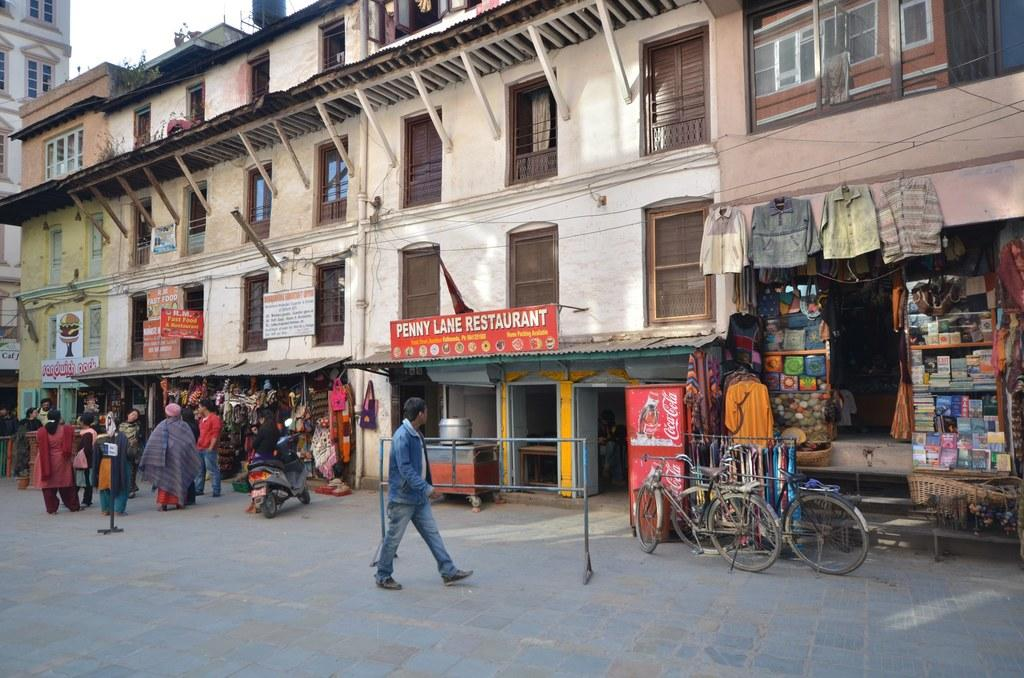<image>
Offer a succinct explanation of the picture presented. an outdoor shopping area with penny lane restaurant in the middle 